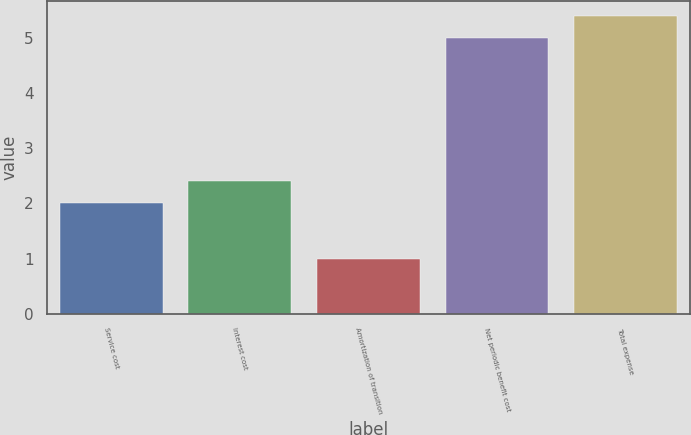Convert chart. <chart><loc_0><loc_0><loc_500><loc_500><bar_chart><fcel>Service cost<fcel>Interest cost<fcel>Amortization of transition<fcel>Net periodic benefit cost<fcel>Total expense<nl><fcel>2<fcel>2.4<fcel>1<fcel>5<fcel>5.4<nl></chart> 